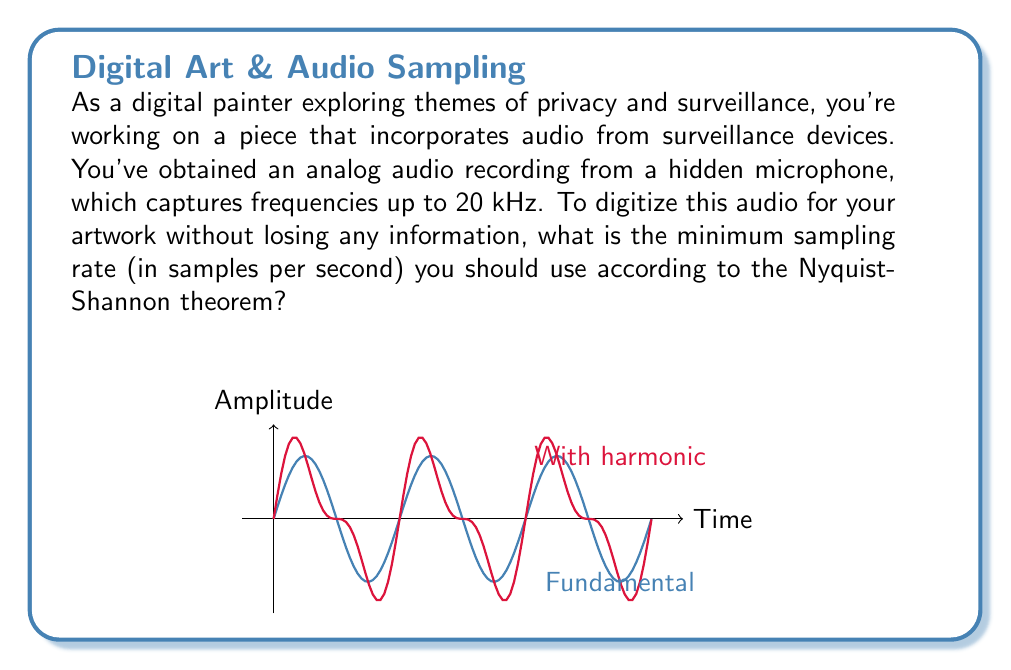Give your solution to this math problem. To determine the optimal sampling rate, we need to apply the Nyquist-Shannon theorem. This theorem states that to accurately reconstruct a continuous signal from its samples, the sampling rate must be at least twice the highest frequency component in the signal.

Let's break this down step-by-step:

1) Identify the highest frequency:
   The audio captures frequencies up to 20 kHz (kilohertz).
   $$f_{max} = 20 \text{ kHz} = 20,000 \text{ Hz}$$

2) Apply the Nyquist-Shannon theorem:
   The minimum sampling rate, also known as the Nyquist rate, is given by:
   $$f_s \geq 2f_{max}$$
   Where $f_s$ is the sampling rate and $f_{max}$ is the highest frequency in the signal.

3) Calculate the minimum sampling rate:
   $$f_s \geq 2 \times 20,000 \text{ Hz}$$
   $$f_s \geq 40,000 \text{ Hz} = 40 \text{ kHz}$$

4) Interpret the result:
   This means you need to sample the audio at least 40,000 times per second to capture all the information without aliasing.

In practice, it's often recommended to use a slightly higher sampling rate to account for non-ideal filters and other real-world considerations. Common standard sampling rates above this minimum include 44.1 kHz (used for CDs) and 48 kHz (common in digital audio).
Answer: 40,000 samples per second 